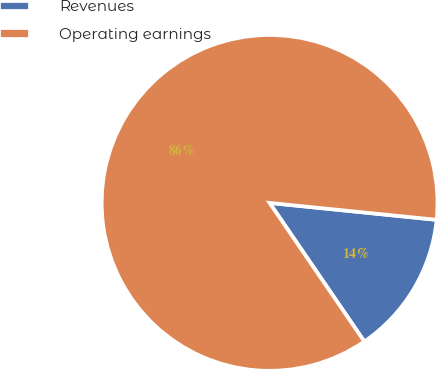Convert chart. <chart><loc_0><loc_0><loc_500><loc_500><pie_chart><fcel>Revenues<fcel>Operating earnings<nl><fcel>13.85%<fcel>86.15%<nl></chart> 